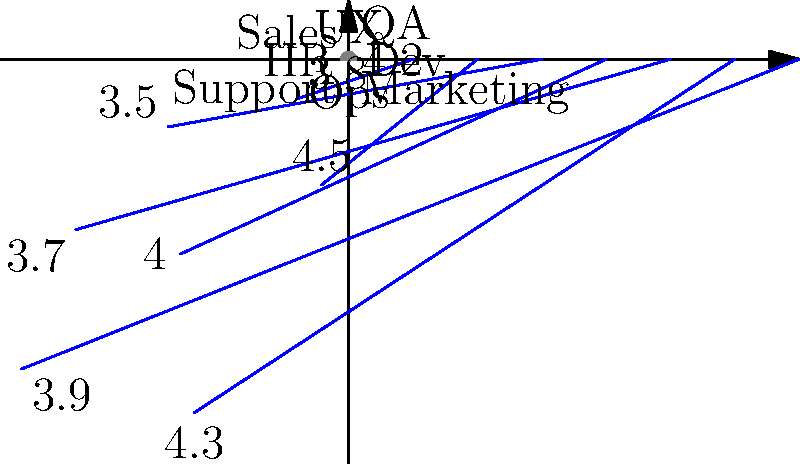Based on the polar plot of employee satisfaction ratings across different departments in a tech company, which department has the highest satisfaction rating, and what insights can you draw about the overall company culture? To answer this question, we need to analyze the polar plot step by step:

1. Identify the departments and their ratings:
   - Dev: 4.2
   - QA: 3.8
   - UX: 4.5
   - Sales: 3.5
   - HR: 4.0
   - Support: 3.7
   - Ops: 4.3
   - Marketing: 3.9

2. Determine the highest satisfaction rating:
   The UX department has the highest rating at 4.5.

3. Analyze the overall company culture:
   a. The ratings range from 3.5 to 4.5, indicating generally positive satisfaction across all departments.
   b. Technical departments (UX, Dev, Ops) have higher ratings (4.5, 4.2, 4.3) compared to non-technical departments.
   c. Sales has the lowest rating (3.5), which might indicate challenges in that department.
   d. The average rating across all departments is approximately 4.0, suggesting a good overall company culture.
   e. The relatively balanced ratings across departments indicate a consistent company culture.

4. Insights for a job seeker in IT:
   a. The high ratings in technical departments (UX, Dev, Ops) suggest a positive work environment for IT professionals.
   b. The company seems to value and invest in its technical teams, which is promising for career growth in IT.
   c. The overall positive ratings across departments indicate a generally healthy company culture, which is important for long-term job satisfaction.
Answer: UX department (4.5); overall positive culture with higher satisfaction in technical departments. 